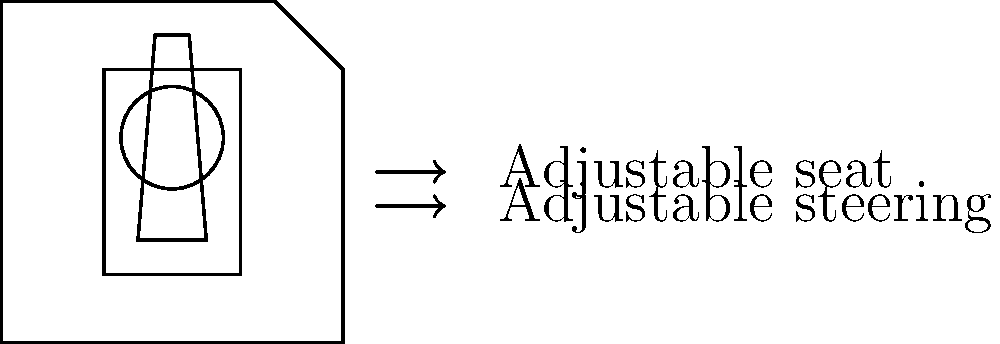As a truck driver, you're aware of the importance of ergonomics in cab design. Consider the diagram showing a simplified truck cab layout. Which of the following adjustments would likely have the most significant impact on reducing lower back strain during long drives?

A) Increasing the size of the steering wheel
B) Adjusting the seat position and angle
C) Changing the color of the dashboard
D) Modifying the shape of the accelerator pedal To answer this question, let's consider the biomechanical principles involved in reducing lower back strain:

1. Posture: Maintaining a neutral spine position is crucial for reducing lower back strain. This is primarily influenced by the seat position and angle.

2. Reach distances: Minimizing reach distances to controls (like the steering wheel) can reduce unnecessary strain on the back muscles.

3. Support: Proper lumbar support from the seat can help maintain the natural curve of the spine.

4. Vibration: Reducing transmission of vehicle vibrations to the driver's body can minimize fatigue and strain.

Analyzing the options:

A) Increasing the size of the steering wheel: While this might slightly affect arm position, it's unlikely to have a significant impact on lower back strain.

B) Adjusting the seat position and angle: This directly affects posture, reach distances, and support. It allows the driver to:
   - Maintain a neutral spine position
   - Optimize the distance to the steering wheel and pedals
   - Adjust lumbar support

C) Changing the color of the dashboard: This has no biomechanical effect on lower back strain.

D) Modifying the shape of the accelerator pedal: While this might slightly affect leg position, its impact on lower back strain is minimal compared to seat adjustments.

Given these considerations, option B (adjusting the seat position and angle) would have the most significant impact on reducing lower back strain during long drives. It allows for optimization of multiple biomechanical factors that directly influence spinal loading and muscle fatigue.
Answer: Adjusting the seat position and angle 